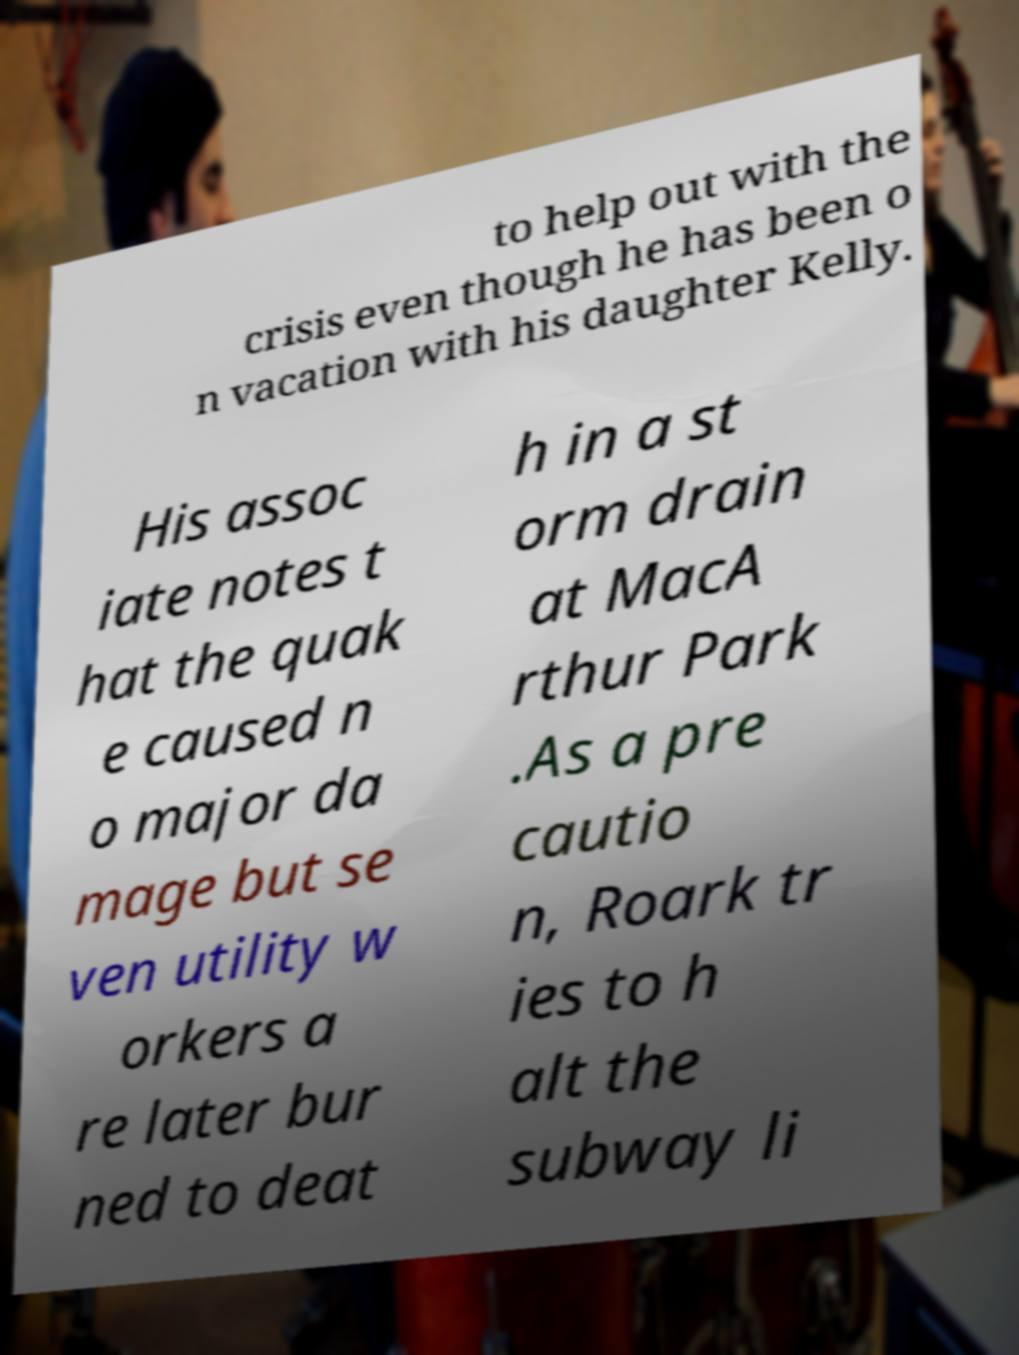Can you accurately transcribe the text from the provided image for me? to help out with the crisis even though he has been o n vacation with his daughter Kelly. His assoc iate notes t hat the quak e caused n o major da mage but se ven utility w orkers a re later bur ned to deat h in a st orm drain at MacA rthur Park .As a pre cautio n, Roark tr ies to h alt the subway li 